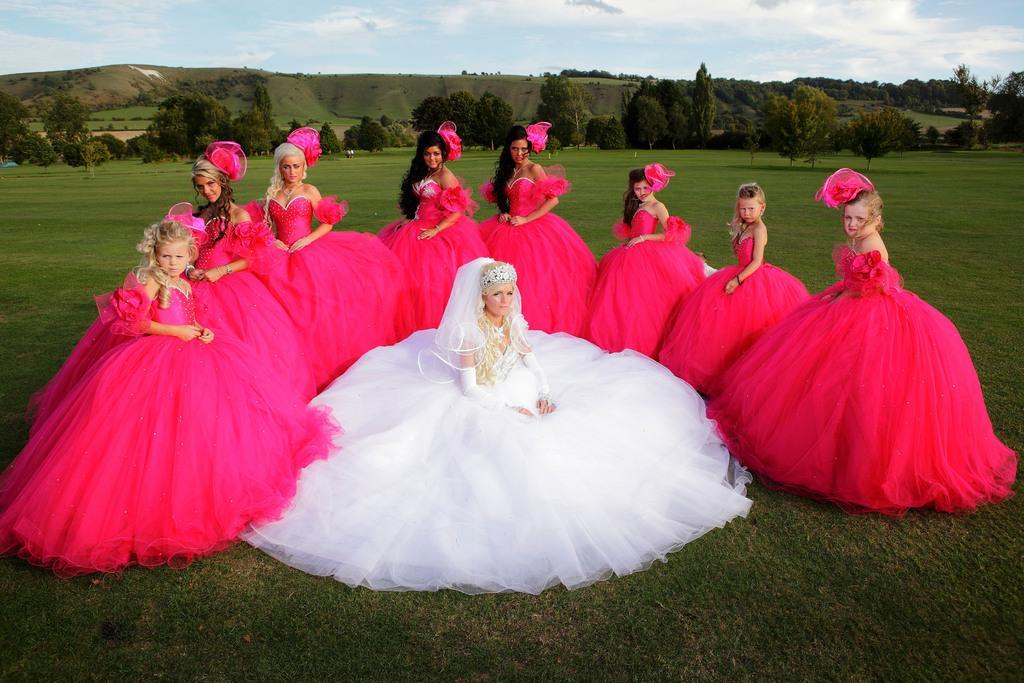In one or two sentences, can you explain what this image depicts? In this image we can see a group of people standing on the grass field. In the background, we can see a group of trees, hills. At the top of the image we can see the sky. 